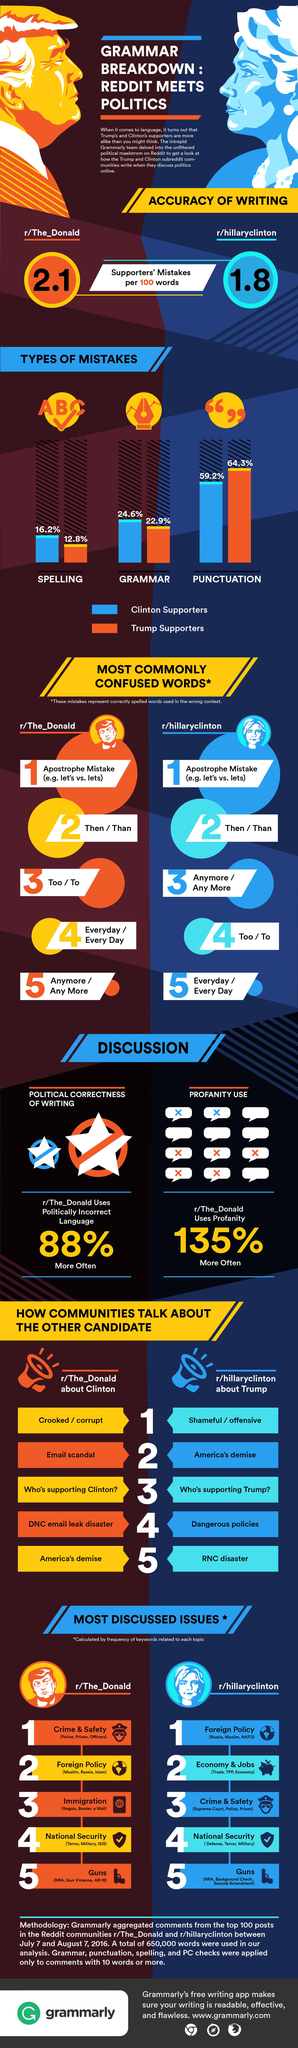Identify some key points in this picture. A survey reveals that 64.3% of Trump supporters make punctuation mistakes. According to a recent study, 16.2% of Hillary Clinton's supporters make spelling mistakes. The number of mistakes made by supporters of each candidate is more per 100 words for Trump. 